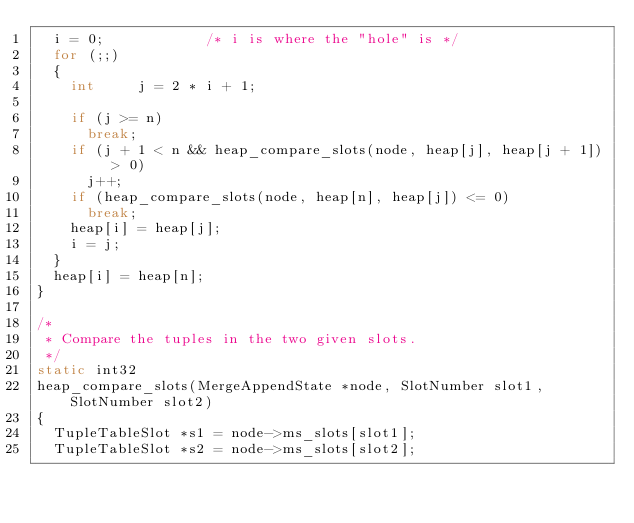Convert code to text. <code><loc_0><loc_0><loc_500><loc_500><_C_>	i = 0;						/* i is where the "hole" is */
	for (;;)
	{
		int			j = 2 * i + 1;

		if (j >= n)
			break;
		if (j + 1 < n && heap_compare_slots(node, heap[j], heap[j + 1]) > 0)
			j++;
		if (heap_compare_slots(node, heap[n], heap[j]) <= 0)
			break;
		heap[i] = heap[j];
		i = j;
	}
	heap[i] = heap[n];
}

/*
 * Compare the tuples in the two given slots.
 */
static int32
heap_compare_slots(MergeAppendState *node, SlotNumber slot1, SlotNumber slot2)
{
	TupleTableSlot *s1 = node->ms_slots[slot1];
	TupleTableSlot *s2 = node->ms_slots[slot2];</code> 